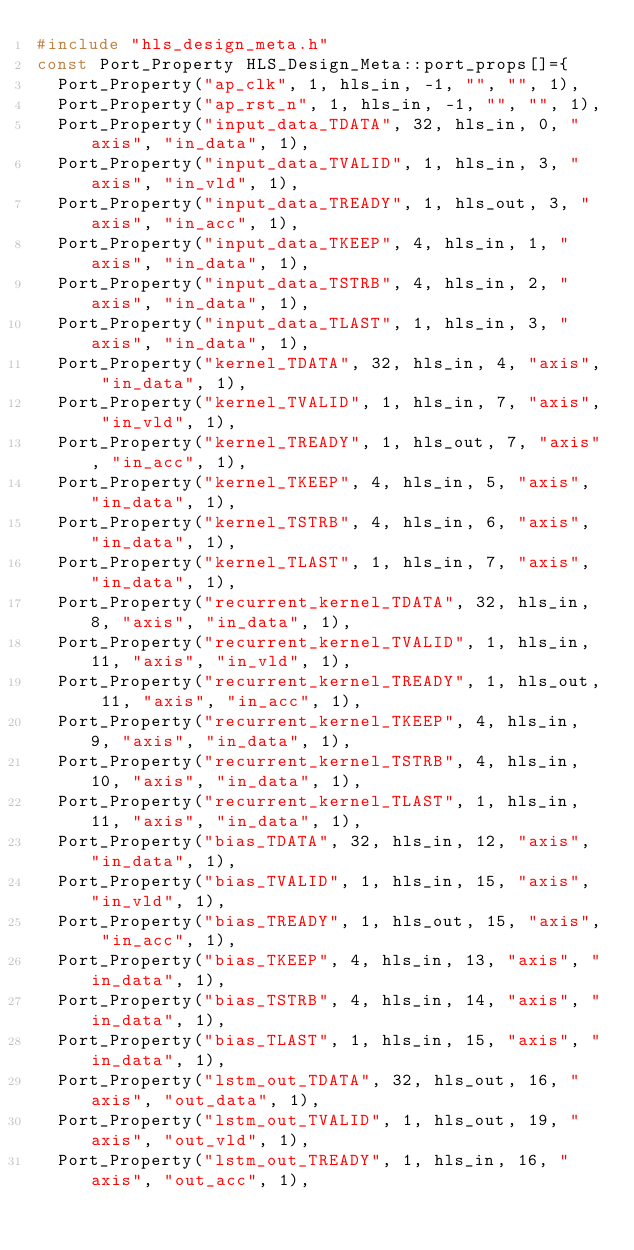Convert code to text. <code><loc_0><loc_0><loc_500><loc_500><_C++_>#include "hls_design_meta.h"
const Port_Property HLS_Design_Meta::port_props[]={
	Port_Property("ap_clk", 1, hls_in, -1, "", "", 1),
	Port_Property("ap_rst_n", 1, hls_in, -1, "", "", 1),
	Port_Property("input_data_TDATA", 32, hls_in, 0, "axis", "in_data", 1),
	Port_Property("input_data_TVALID", 1, hls_in, 3, "axis", "in_vld", 1),
	Port_Property("input_data_TREADY", 1, hls_out, 3, "axis", "in_acc", 1),
	Port_Property("input_data_TKEEP", 4, hls_in, 1, "axis", "in_data", 1),
	Port_Property("input_data_TSTRB", 4, hls_in, 2, "axis", "in_data", 1),
	Port_Property("input_data_TLAST", 1, hls_in, 3, "axis", "in_data", 1),
	Port_Property("kernel_TDATA", 32, hls_in, 4, "axis", "in_data", 1),
	Port_Property("kernel_TVALID", 1, hls_in, 7, "axis", "in_vld", 1),
	Port_Property("kernel_TREADY", 1, hls_out, 7, "axis", "in_acc", 1),
	Port_Property("kernel_TKEEP", 4, hls_in, 5, "axis", "in_data", 1),
	Port_Property("kernel_TSTRB", 4, hls_in, 6, "axis", "in_data", 1),
	Port_Property("kernel_TLAST", 1, hls_in, 7, "axis", "in_data", 1),
	Port_Property("recurrent_kernel_TDATA", 32, hls_in, 8, "axis", "in_data", 1),
	Port_Property("recurrent_kernel_TVALID", 1, hls_in, 11, "axis", "in_vld", 1),
	Port_Property("recurrent_kernel_TREADY", 1, hls_out, 11, "axis", "in_acc", 1),
	Port_Property("recurrent_kernel_TKEEP", 4, hls_in, 9, "axis", "in_data", 1),
	Port_Property("recurrent_kernel_TSTRB", 4, hls_in, 10, "axis", "in_data", 1),
	Port_Property("recurrent_kernel_TLAST", 1, hls_in, 11, "axis", "in_data", 1),
	Port_Property("bias_TDATA", 32, hls_in, 12, "axis", "in_data", 1),
	Port_Property("bias_TVALID", 1, hls_in, 15, "axis", "in_vld", 1),
	Port_Property("bias_TREADY", 1, hls_out, 15, "axis", "in_acc", 1),
	Port_Property("bias_TKEEP", 4, hls_in, 13, "axis", "in_data", 1),
	Port_Property("bias_TSTRB", 4, hls_in, 14, "axis", "in_data", 1),
	Port_Property("bias_TLAST", 1, hls_in, 15, "axis", "in_data", 1),
	Port_Property("lstm_out_TDATA", 32, hls_out, 16, "axis", "out_data", 1),
	Port_Property("lstm_out_TVALID", 1, hls_out, 19, "axis", "out_vld", 1),
	Port_Property("lstm_out_TREADY", 1, hls_in, 16, "axis", "out_acc", 1),</code> 